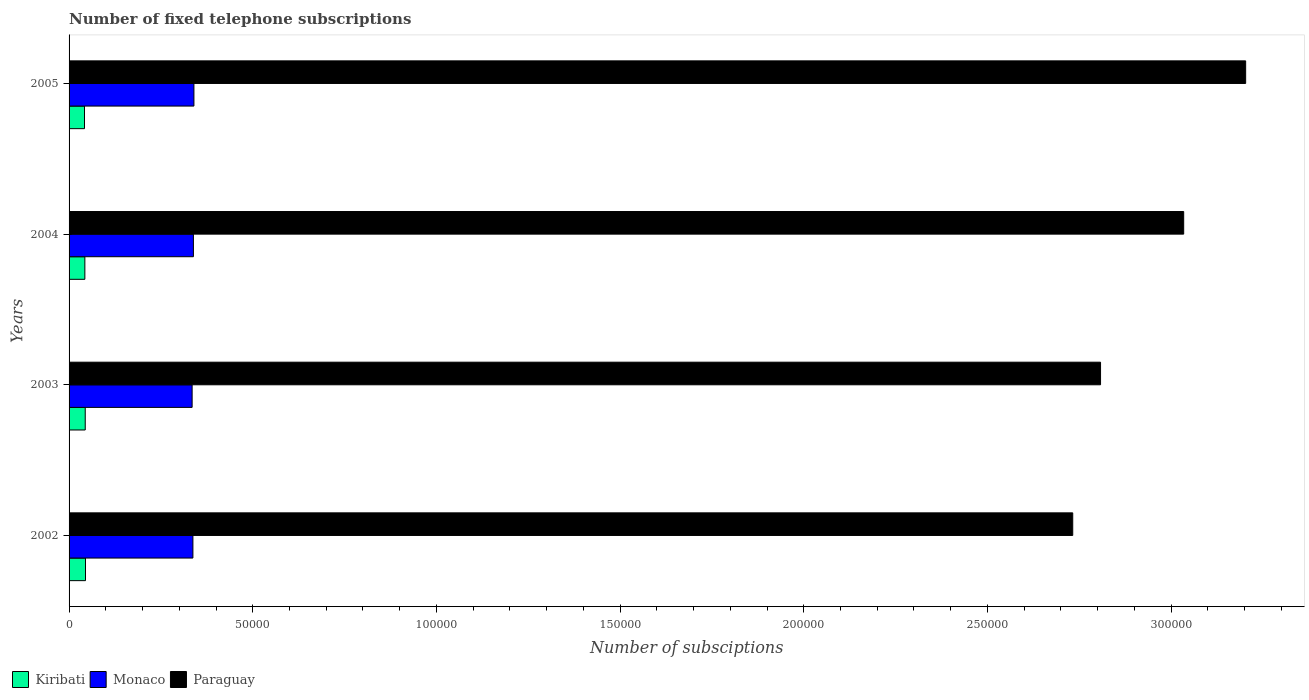How many different coloured bars are there?
Keep it short and to the point. 3. How many bars are there on the 1st tick from the bottom?
Offer a very short reply. 3. What is the number of fixed telephone subscriptions in Kiribati in 2002?
Provide a short and direct response. 4474. Across all years, what is the maximum number of fixed telephone subscriptions in Kiribati?
Offer a very short reply. 4474. Across all years, what is the minimum number of fixed telephone subscriptions in Kiribati?
Offer a terse response. 4200. In which year was the number of fixed telephone subscriptions in Paraguay maximum?
Offer a very short reply. 2005. What is the total number of fixed telephone subscriptions in Paraguay in the graph?
Offer a terse response. 1.18e+06. What is the difference between the number of fixed telephone subscriptions in Kiribati in 2002 and that in 2003?
Offer a very short reply. 74. What is the difference between the number of fixed telephone subscriptions in Paraguay in 2003 and the number of fixed telephone subscriptions in Monaco in 2002?
Provide a succinct answer. 2.47e+05. What is the average number of fixed telephone subscriptions in Paraguay per year?
Offer a very short reply. 2.94e+05. In the year 2005, what is the difference between the number of fixed telephone subscriptions in Monaco and number of fixed telephone subscriptions in Kiribati?
Give a very brief answer. 2.98e+04. In how many years, is the number of fixed telephone subscriptions in Paraguay greater than 170000 ?
Offer a very short reply. 4. What is the ratio of the number of fixed telephone subscriptions in Monaco in 2002 to that in 2005?
Offer a terse response. 0.99. Is the number of fixed telephone subscriptions in Monaco in 2002 less than that in 2005?
Ensure brevity in your answer.  Yes. Is the difference between the number of fixed telephone subscriptions in Monaco in 2003 and 2005 greater than the difference between the number of fixed telephone subscriptions in Kiribati in 2003 and 2005?
Provide a succinct answer. No. What is the difference between the highest and the second highest number of fixed telephone subscriptions in Monaco?
Offer a very short reply. 141. What is the difference between the highest and the lowest number of fixed telephone subscriptions in Paraguay?
Give a very brief answer. 4.71e+04. In how many years, is the number of fixed telephone subscriptions in Paraguay greater than the average number of fixed telephone subscriptions in Paraguay taken over all years?
Provide a short and direct response. 2. What does the 1st bar from the top in 2002 represents?
Keep it short and to the point. Paraguay. What does the 2nd bar from the bottom in 2005 represents?
Offer a terse response. Monaco. How many bars are there?
Offer a terse response. 12. Are all the bars in the graph horizontal?
Offer a terse response. Yes. What is the difference between two consecutive major ticks on the X-axis?
Offer a very short reply. 5.00e+04. Are the values on the major ticks of X-axis written in scientific E-notation?
Make the answer very short. No. Where does the legend appear in the graph?
Offer a terse response. Bottom left. How many legend labels are there?
Keep it short and to the point. 3. What is the title of the graph?
Offer a very short reply. Number of fixed telephone subscriptions. Does "Timor-Leste" appear as one of the legend labels in the graph?
Make the answer very short. No. What is the label or title of the X-axis?
Provide a short and direct response. Number of subsciptions. What is the label or title of the Y-axis?
Give a very brief answer. Years. What is the Number of subsciptions in Kiribati in 2002?
Provide a succinct answer. 4474. What is the Number of subsciptions of Monaco in 2002?
Your response must be concise. 3.37e+04. What is the Number of subsciptions of Paraguay in 2002?
Your answer should be compact. 2.73e+05. What is the Number of subsciptions in Kiribati in 2003?
Your answer should be compact. 4400. What is the Number of subsciptions in Monaco in 2003?
Provide a succinct answer. 3.35e+04. What is the Number of subsciptions of Paraguay in 2003?
Offer a very short reply. 2.81e+05. What is the Number of subsciptions of Kiribati in 2004?
Keep it short and to the point. 4300. What is the Number of subsciptions of Monaco in 2004?
Provide a succinct answer. 3.38e+04. What is the Number of subsciptions of Paraguay in 2004?
Make the answer very short. 3.03e+05. What is the Number of subsciptions in Kiribati in 2005?
Offer a terse response. 4200. What is the Number of subsciptions of Monaco in 2005?
Provide a short and direct response. 3.40e+04. What is the Number of subsciptions of Paraguay in 2005?
Provide a succinct answer. 3.20e+05. Across all years, what is the maximum Number of subsciptions in Kiribati?
Your answer should be very brief. 4474. Across all years, what is the maximum Number of subsciptions of Monaco?
Provide a succinct answer. 3.40e+04. Across all years, what is the maximum Number of subsciptions in Paraguay?
Give a very brief answer. 3.20e+05. Across all years, what is the minimum Number of subsciptions of Kiribati?
Your answer should be very brief. 4200. Across all years, what is the minimum Number of subsciptions in Monaco?
Ensure brevity in your answer.  3.35e+04. Across all years, what is the minimum Number of subsciptions of Paraguay?
Keep it short and to the point. 2.73e+05. What is the total Number of subsciptions of Kiribati in the graph?
Keep it short and to the point. 1.74e+04. What is the total Number of subsciptions in Monaco in the graph?
Give a very brief answer. 1.35e+05. What is the total Number of subsciptions of Paraguay in the graph?
Ensure brevity in your answer.  1.18e+06. What is the difference between the Number of subsciptions in Kiribati in 2002 and that in 2003?
Offer a terse response. 74. What is the difference between the Number of subsciptions of Monaco in 2002 and that in 2003?
Ensure brevity in your answer.  212. What is the difference between the Number of subsciptions of Paraguay in 2002 and that in 2003?
Keep it short and to the point. -7572. What is the difference between the Number of subsciptions of Kiribati in 2002 and that in 2004?
Your response must be concise. 174. What is the difference between the Number of subsciptions in Monaco in 2002 and that in 2004?
Ensure brevity in your answer.  -134. What is the difference between the Number of subsciptions in Paraguay in 2002 and that in 2004?
Offer a terse response. -3.02e+04. What is the difference between the Number of subsciptions of Kiribati in 2002 and that in 2005?
Give a very brief answer. 274. What is the difference between the Number of subsciptions in Monaco in 2002 and that in 2005?
Your answer should be compact. -275. What is the difference between the Number of subsciptions in Paraguay in 2002 and that in 2005?
Keep it short and to the point. -4.71e+04. What is the difference between the Number of subsciptions in Monaco in 2003 and that in 2004?
Keep it short and to the point. -346. What is the difference between the Number of subsciptions of Paraguay in 2003 and that in 2004?
Your answer should be very brief. -2.26e+04. What is the difference between the Number of subsciptions of Kiribati in 2003 and that in 2005?
Provide a succinct answer. 200. What is the difference between the Number of subsciptions of Monaco in 2003 and that in 2005?
Provide a succinct answer. -487. What is the difference between the Number of subsciptions of Paraguay in 2003 and that in 2005?
Give a very brief answer. -3.95e+04. What is the difference between the Number of subsciptions in Monaco in 2004 and that in 2005?
Keep it short and to the point. -141. What is the difference between the Number of subsciptions in Paraguay in 2004 and that in 2005?
Your answer should be very brief. -1.69e+04. What is the difference between the Number of subsciptions of Kiribati in 2002 and the Number of subsciptions of Monaco in 2003?
Offer a terse response. -2.90e+04. What is the difference between the Number of subsciptions of Kiribati in 2002 and the Number of subsciptions of Paraguay in 2003?
Give a very brief answer. -2.76e+05. What is the difference between the Number of subsciptions in Monaco in 2002 and the Number of subsciptions in Paraguay in 2003?
Provide a succinct answer. -2.47e+05. What is the difference between the Number of subsciptions in Kiribati in 2002 and the Number of subsciptions in Monaco in 2004?
Give a very brief answer. -2.94e+04. What is the difference between the Number of subsciptions of Kiribati in 2002 and the Number of subsciptions of Paraguay in 2004?
Offer a very short reply. -2.99e+05. What is the difference between the Number of subsciptions of Monaco in 2002 and the Number of subsciptions of Paraguay in 2004?
Your answer should be compact. -2.70e+05. What is the difference between the Number of subsciptions in Kiribati in 2002 and the Number of subsciptions in Monaco in 2005?
Your answer should be compact. -2.95e+04. What is the difference between the Number of subsciptions in Kiribati in 2002 and the Number of subsciptions in Paraguay in 2005?
Provide a short and direct response. -3.16e+05. What is the difference between the Number of subsciptions of Monaco in 2002 and the Number of subsciptions of Paraguay in 2005?
Your response must be concise. -2.87e+05. What is the difference between the Number of subsciptions in Kiribati in 2003 and the Number of subsciptions in Monaco in 2004?
Keep it short and to the point. -2.94e+04. What is the difference between the Number of subsciptions of Kiribati in 2003 and the Number of subsciptions of Paraguay in 2004?
Offer a terse response. -2.99e+05. What is the difference between the Number of subsciptions of Monaco in 2003 and the Number of subsciptions of Paraguay in 2004?
Keep it short and to the point. -2.70e+05. What is the difference between the Number of subsciptions in Kiribati in 2003 and the Number of subsciptions in Monaco in 2005?
Your answer should be very brief. -2.96e+04. What is the difference between the Number of subsciptions in Kiribati in 2003 and the Number of subsciptions in Paraguay in 2005?
Give a very brief answer. -3.16e+05. What is the difference between the Number of subsciptions of Monaco in 2003 and the Number of subsciptions of Paraguay in 2005?
Provide a succinct answer. -2.87e+05. What is the difference between the Number of subsciptions in Kiribati in 2004 and the Number of subsciptions in Monaco in 2005?
Ensure brevity in your answer.  -2.97e+04. What is the difference between the Number of subsciptions in Kiribati in 2004 and the Number of subsciptions in Paraguay in 2005?
Keep it short and to the point. -3.16e+05. What is the difference between the Number of subsciptions in Monaco in 2004 and the Number of subsciptions in Paraguay in 2005?
Your response must be concise. -2.86e+05. What is the average Number of subsciptions of Kiribati per year?
Provide a succinct answer. 4343.5. What is the average Number of subsciptions of Monaco per year?
Offer a very short reply. 3.38e+04. What is the average Number of subsciptions of Paraguay per year?
Make the answer very short. 2.94e+05. In the year 2002, what is the difference between the Number of subsciptions of Kiribati and Number of subsciptions of Monaco?
Provide a short and direct response. -2.92e+04. In the year 2002, what is the difference between the Number of subsciptions of Kiribati and Number of subsciptions of Paraguay?
Your response must be concise. -2.69e+05. In the year 2002, what is the difference between the Number of subsciptions of Monaco and Number of subsciptions of Paraguay?
Your response must be concise. -2.40e+05. In the year 2003, what is the difference between the Number of subsciptions of Kiribati and Number of subsciptions of Monaco?
Ensure brevity in your answer.  -2.91e+04. In the year 2003, what is the difference between the Number of subsciptions in Kiribati and Number of subsciptions in Paraguay?
Make the answer very short. -2.76e+05. In the year 2003, what is the difference between the Number of subsciptions of Monaco and Number of subsciptions of Paraguay?
Provide a short and direct response. -2.47e+05. In the year 2004, what is the difference between the Number of subsciptions of Kiribati and Number of subsciptions of Monaco?
Provide a short and direct response. -2.95e+04. In the year 2004, what is the difference between the Number of subsciptions in Kiribati and Number of subsciptions in Paraguay?
Provide a succinct answer. -2.99e+05. In the year 2004, what is the difference between the Number of subsciptions in Monaco and Number of subsciptions in Paraguay?
Ensure brevity in your answer.  -2.70e+05. In the year 2005, what is the difference between the Number of subsciptions of Kiribati and Number of subsciptions of Monaco?
Offer a terse response. -2.98e+04. In the year 2005, what is the difference between the Number of subsciptions in Kiribati and Number of subsciptions in Paraguay?
Your answer should be compact. -3.16e+05. In the year 2005, what is the difference between the Number of subsciptions in Monaco and Number of subsciptions in Paraguay?
Make the answer very short. -2.86e+05. What is the ratio of the Number of subsciptions in Kiribati in 2002 to that in 2003?
Your answer should be very brief. 1.02. What is the ratio of the Number of subsciptions in Monaco in 2002 to that in 2003?
Your response must be concise. 1.01. What is the ratio of the Number of subsciptions of Paraguay in 2002 to that in 2003?
Provide a succinct answer. 0.97. What is the ratio of the Number of subsciptions in Kiribati in 2002 to that in 2004?
Provide a succinct answer. 1.04. What is the ratio of the Number of subsciptions in Monaco in 2002 to that in 2004?
Your response must be concise. 1. What is the ratio of the Number of subsciptions in Paraguay in 2002 to that in 2004?
Your response must be concise. 0.9. What is the ratio of the Number of subsciptions of Kiribati in 2002 to that in 2005?
Give a very brief answer. 1.07. What is the ratio of the Number of subsciptions in Monaco in 2002 to that in 2005?
Provide a short and direct response. 0.99. What is the ratio of the Number of subsciptions of Paraguay in 2002 to that in 2005?
Provide a succinct answer. 0.85. What is the ratio of the Number of subsciptions of Kiribati in 2003 to that in 2004?
Ensure brevity in your answer.  1.02. What is the ratio of the Number of subsciptions in Paraguay in 2003 to that in 2004?
Offer a terse response. 0.93. What is the ratio of the Number of subsciptions of Kiribati in 2003 to that in 2005?
Your answer should be compact. 1.05. What is the ratio of the Number of subsciptions in Monaco in 2003 to that in 2005?
Provide a short and direct response. 0.99. What is the ratio of the Number of subsciptions of Paraguay in 2003 to that in 2005?
Give a very brief answer. 0.88. What is the ratio of the Number of subsciptions of Kiribati in 2004 to that in 2005?
Give a very brief answer. 1.02. What is the ratio of the Number of subsciptions of Monaco in 2004 to that in 2005?
Make the answer very short. 1. What is the ratio of the Number of subsciptions in Paraguay in 2004 to that in 2005?
Keep it short and to the point. 0.95. What is the difference between the highest and the second highest Number of subsciptions in Kiribati?
Keep it short and to the point. 74. What is the difference between the highest and the second highest Number of subsciptions in Monaco?
Offer a terse response. 141. What is the difference between the highest and the second highest Number of subsciptions in Paraguay?
Your answer should be compact. 1.69e+04. What is the difference between the highest and the lowest Number of subsciptions in Kiribati?
Your answer should be compact. 274. What is the difference between the highest and the lowest Number of subsciptions of Monaco?
Offer a very short reply. 487. What is the difference between the highest and the lowest Number of subsciptions in Paraguay?
Your response must be concise. 4.71e+04. 